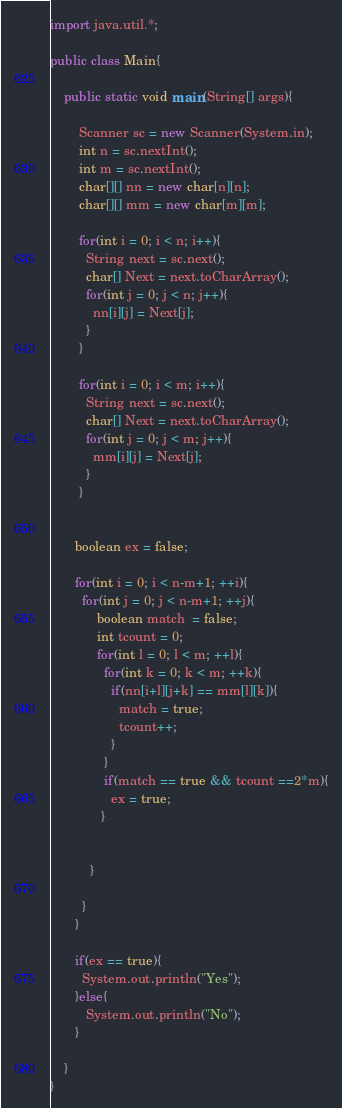Convert code to text. <code><loc_0><loc_0><loc_500><loc_500><_Java_>import java.util.*;

public class Main{

	public static void main(String[] args){

		Scanner sc = new Scanner(System.in);
        int n = sc.nextInt();
        int m = sc.nextInt();
        char[][] nn = new char[n][n];
        char[][] mm = new char[m][m];
       
        for(int i = 0; i < n; i++){
          String next = sc.next();
          char[] Next = next.toCharArray();
          for(int j = 0; j < n; j++){
            nn[i][j] = Next[j];
          }
        }
      
        for(int i = 0; i < m; i++){
          String next = sc.next();
          char[] Next = next.toCharArray();
          for(int j = 0; j < m; j++){
            mm[i][j] = Next[j];
          }
        }

      
       boolean ex = false; 
       
       for(int i = 0; i < n-m+1; ++i){
         for(int j = 0; j < n-m+1; ++j){
             boolean match  = false;
             int tcount = 0;
             for(int l = 0; l < m; ++l){
               for(int k = 0; k < m; ++k){
                 if(nn[i+l][j+k] == mm[l][k]){
                   match = true;
                   tcount++;
                 }
               }
               if(match == true && tcount ==2*m){
                 ex = true;
              }
               
             
           }
           
         }
       }
      
       if(ex == true){
         System.out.println("Yes");
       }else{
          System.out.println("No");
       }

	}
}</code> 